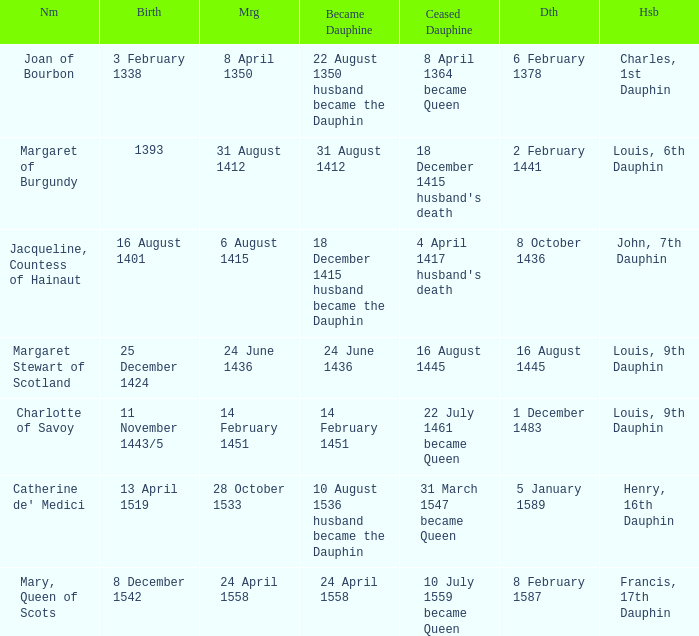Who has a birth of 16 august 1401? Jacqueline, Countess of Hainaut. 